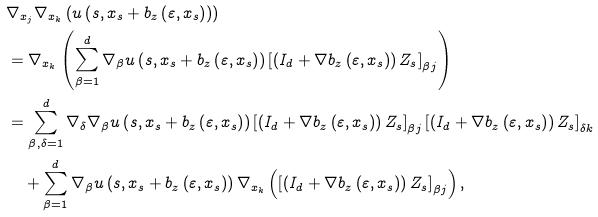<formula> <loc_0><loc_0><loc_500><loc_500>& \nabla _ { x _ { j } } \nabla _ { x _ { k } } \left ( u \left ( s , x _ { s } + b _ { z } \left ( \varepsilon , x _ { s } \right ) \right ) \right ) \\ & = \nabla _ { x _ { k } } \left ( \sum _ { \beta = 1 } ^ { d } \nabla _ { \beta } u \left ( s , x _ { s } + b _ { z } \left ( \varepsilon , x _ { s } \right ) \right ) \left [ \left ( I _ { d } + \nabla b _ { z } \left ( \varepsilon , x _ { s } \right ) \right ) Z _ { s } \right ] _ { \beta j } \right ) \\ & = \sum _ { \beta , \delta = 1 } ^ { d } \nabla _ { \delta } \nabla _ { \beta } u \left ( s , x _ { s } + b _ { z } \left ( \varepsilon , x _ { s } \right ) \right ) \left [ \left ( I _ { d } + \nabla b _ { z } \left ( \varepsilon , x _ { s } \right ) \right ) Z _ { s } \right ] _ { \beta j } \left [ \left ( I _ { d } + \nabla b _ { z } \left ( \varepsilon , x _ { s } \right ) \right ) Z _ { s } \right ] _ { \delta k } \\ & \quad + \sum _ { \beta = 1 } ^ { d } \nabla _ { \beta } u \left ( s , x _ { s } + b _ { z } \left ( \varepsilon , x _ { s } \right ) \right ) \nabla _ { x _ { k } } \left ( \left [ \left ( I _ { d } + \nabla b _ { z } \left ( \varepsilon , x _ { s } \right ) \right ) Z _ { s } \right ] _ { \beta j } \right ) ,</formula> 